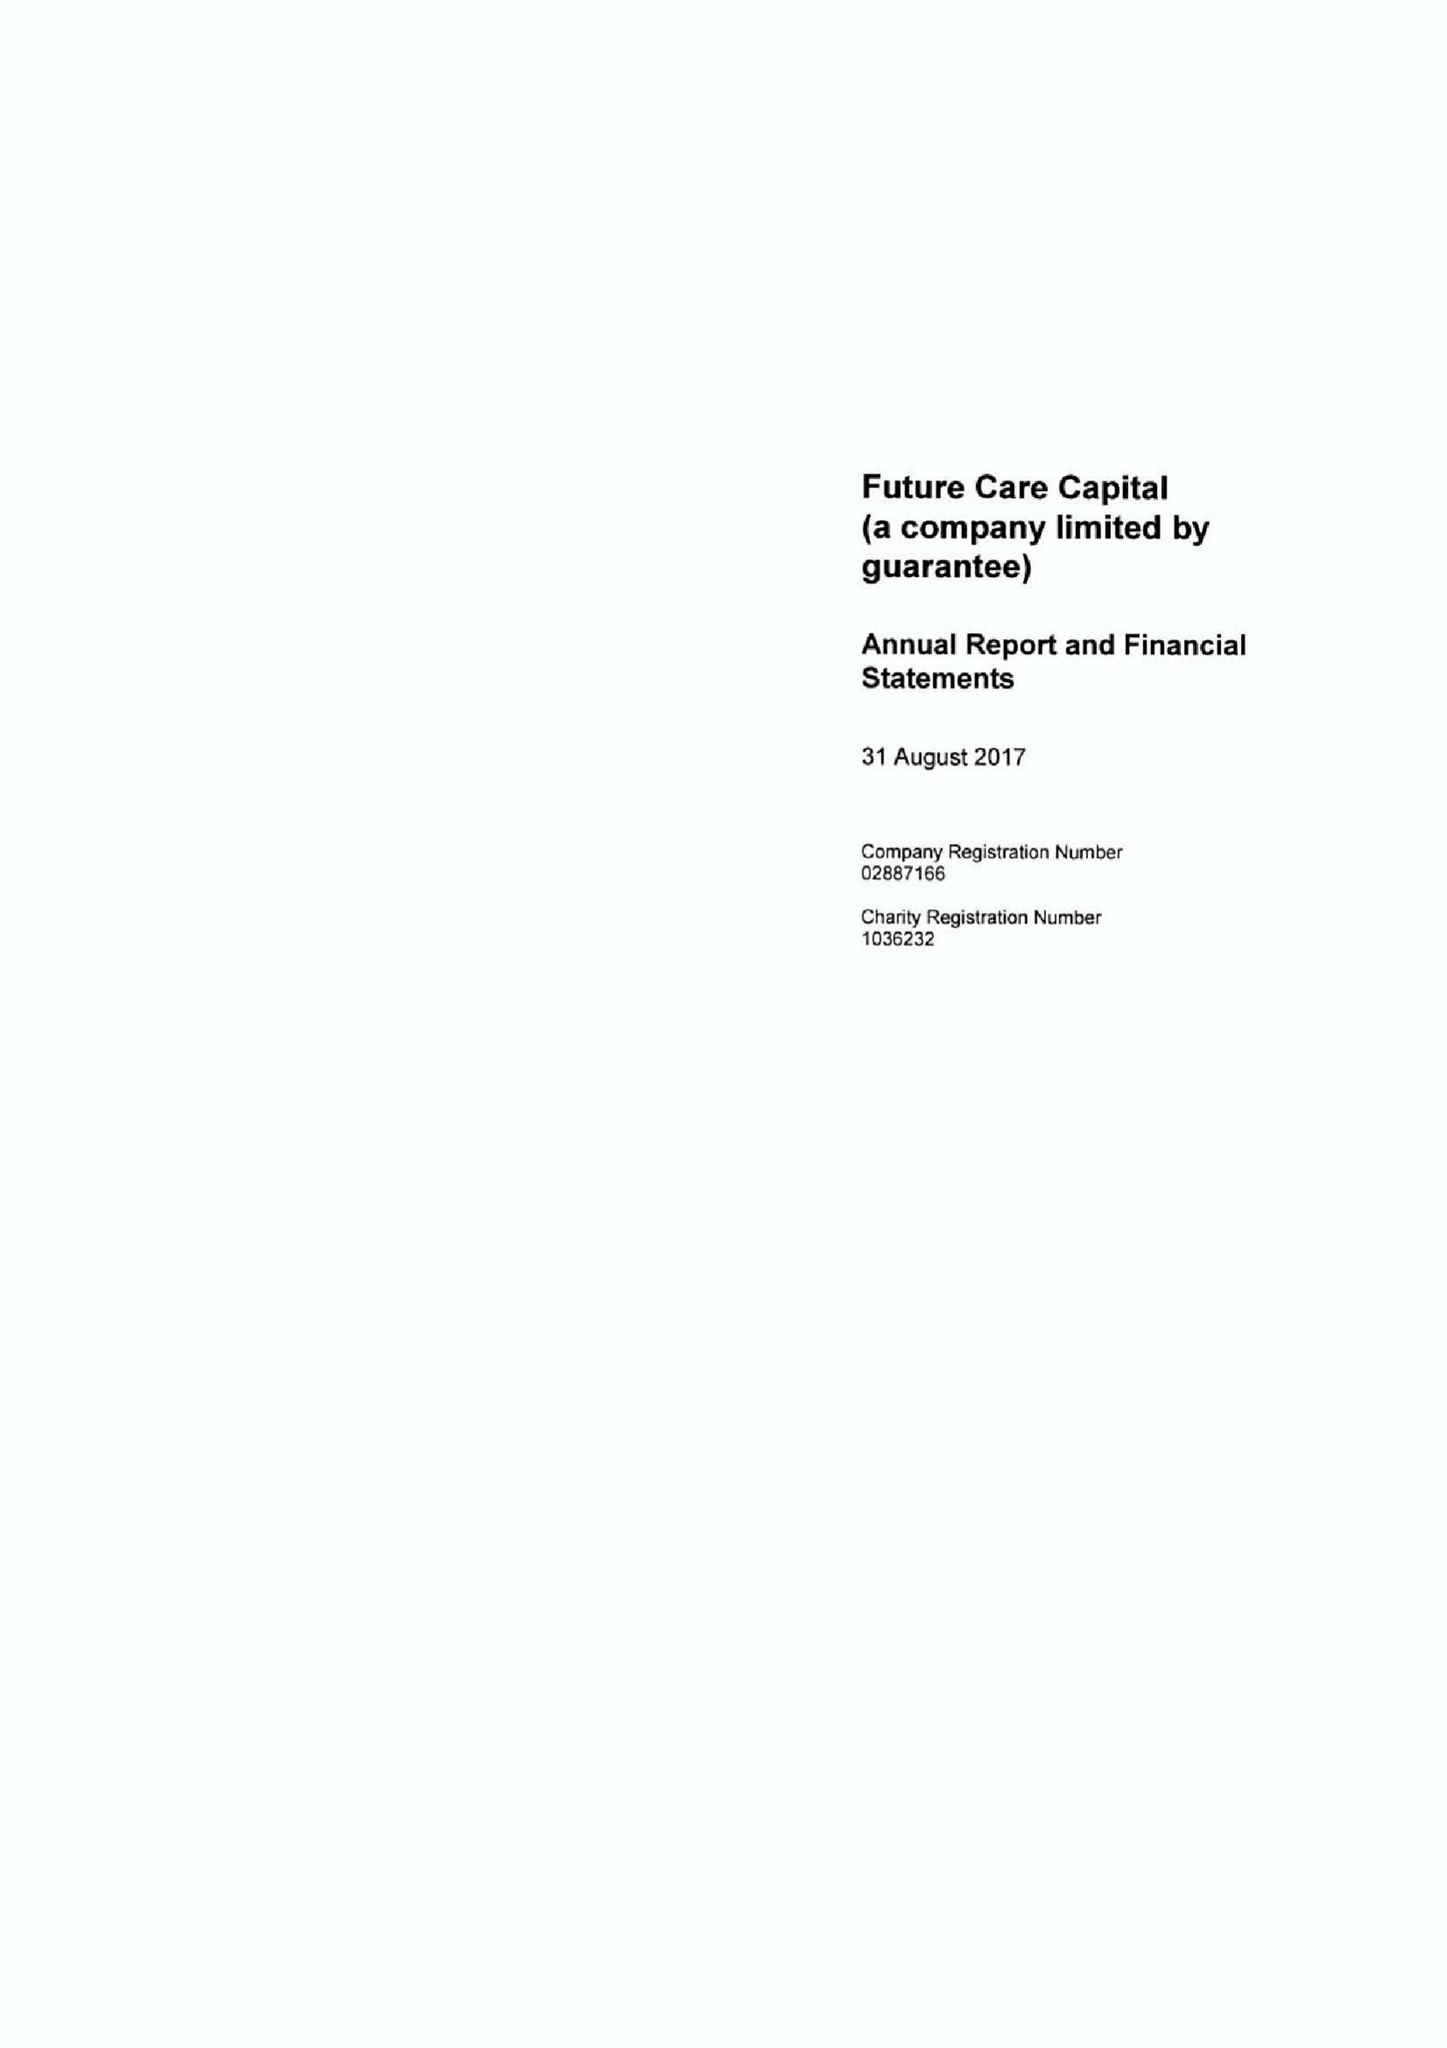What is the value for the charity_name?
Answer the question using a single word or phrase. Future Care Capital 